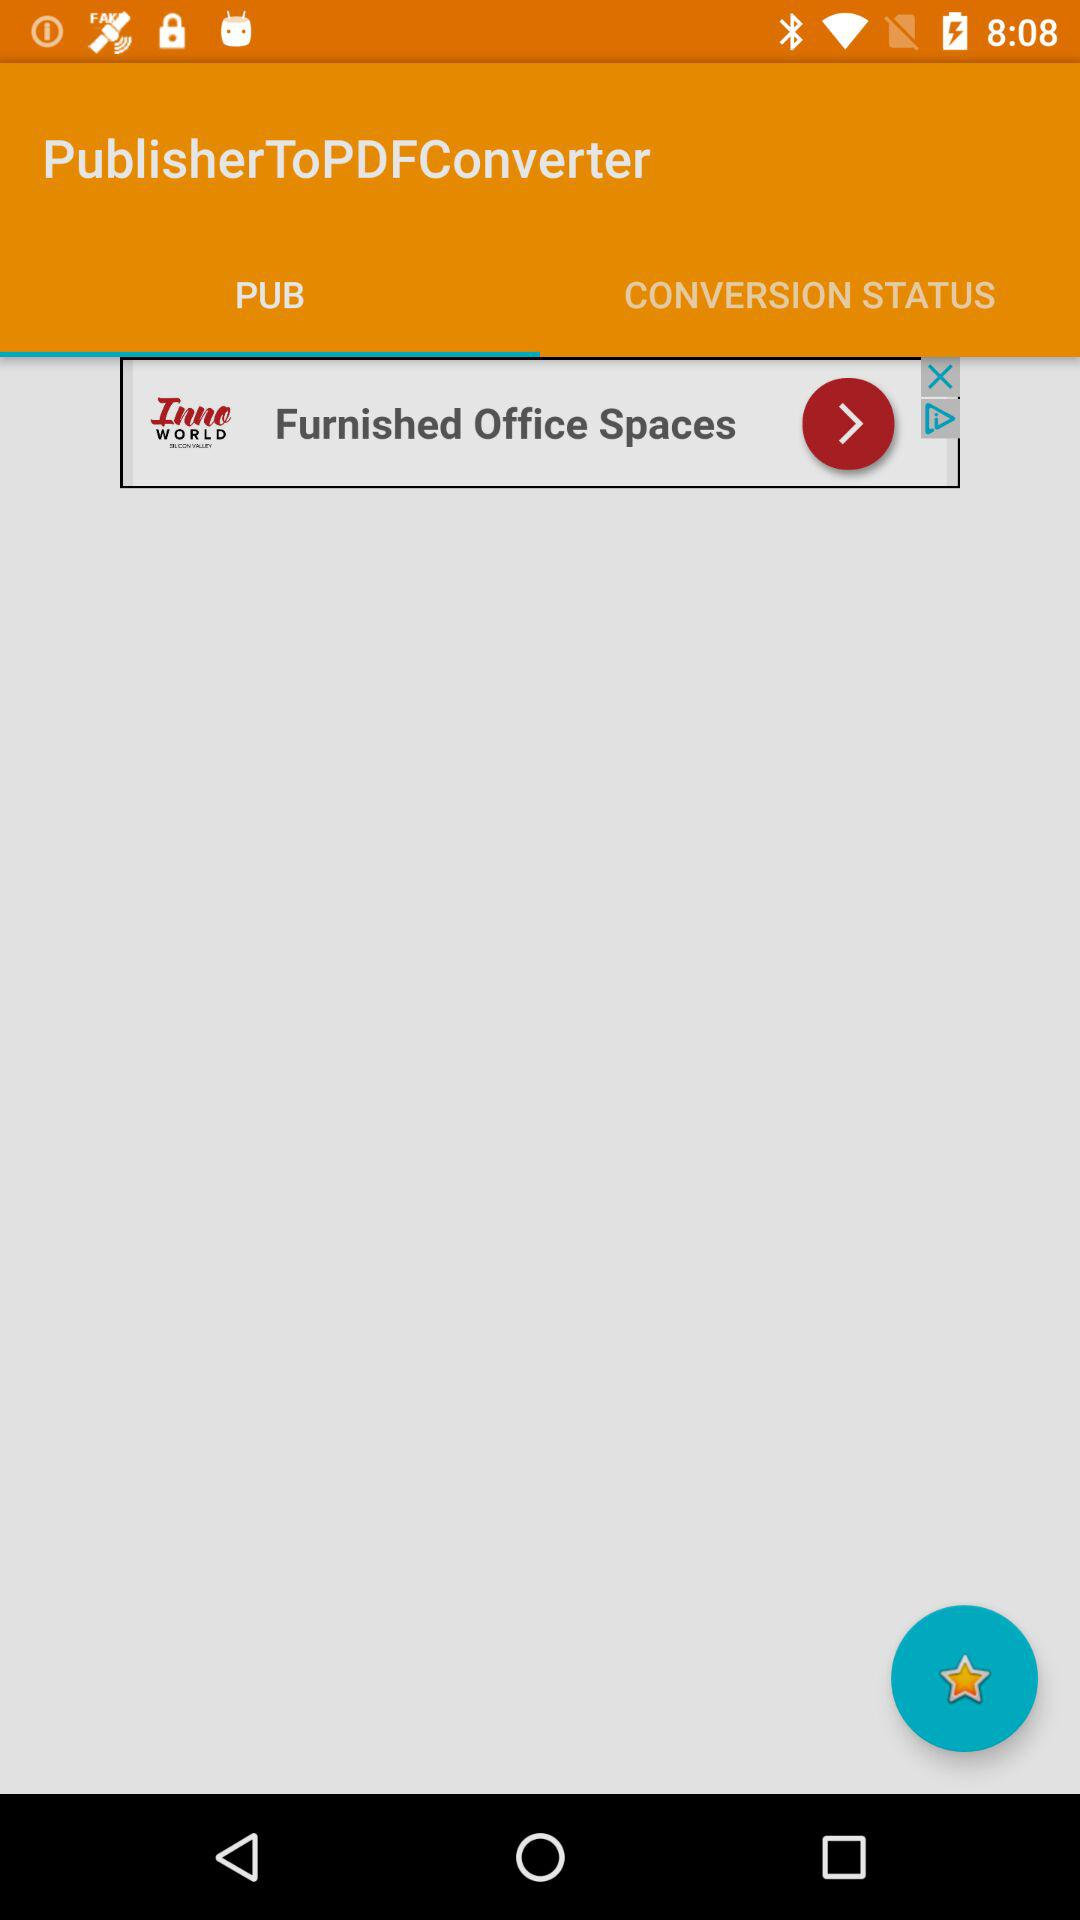What tab am I on? You are on the "PUB" tab. 